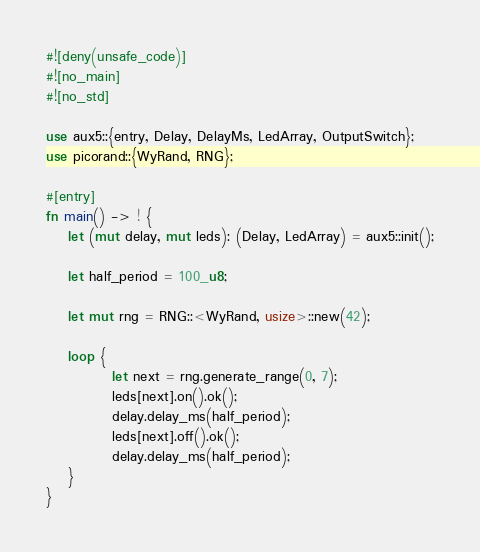Convert code to text. <code><loc_0><loc_0><loc_500><loc_500><_Rust_>#![deny(unsafe_code)]
#![no_main]
#![no_std]

use aux5::{entry, Delay, DelayMs, LedArray, OutputSwitch};
use picorand::{WyRand, RNG};

#[entry]
fn main() -> ! {
    let (mut delay, mut leds): (Delay, LedArray) = aux5::init();

    let half_period = 100_u8;

    let mut rng = RNG::<WyRand, usize>::new(42);

    loop {
            let next = rng.generate_range(0, 7);
            leds[next].on().ok();
            delay.delay_ms(half_period);
            leds[next].off().ok();
            delay.delay_ms(half_period);
    }
}
</code> 